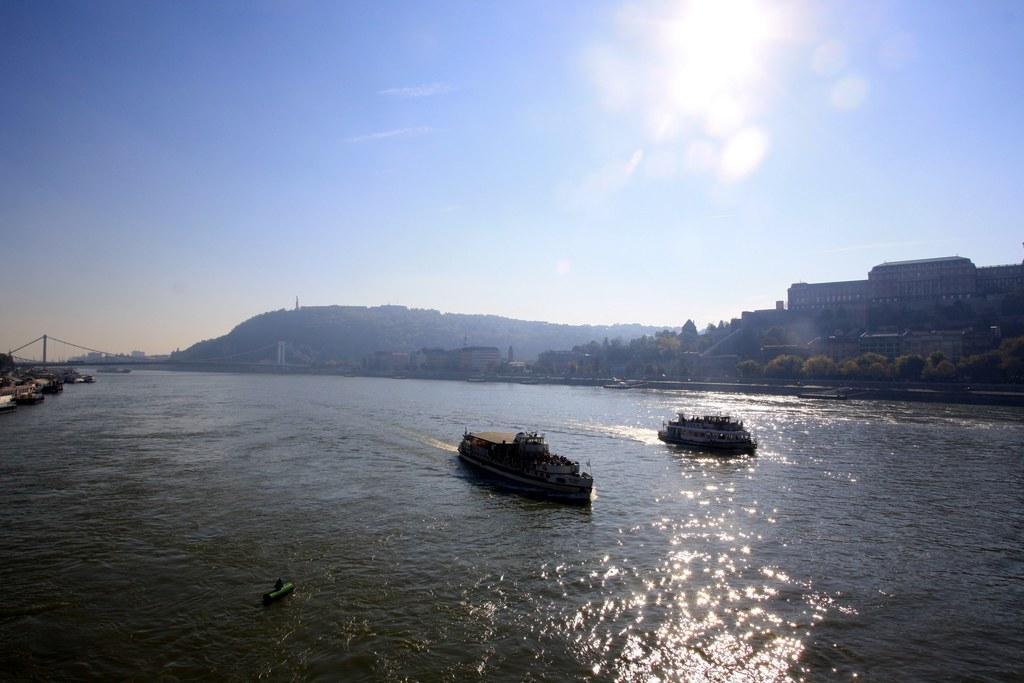How would you summarize this image in a sentence or two? In this picture we can see there are ships on the water. Behind the ships, there are trees, buildings, a hill and the sky. On the left side of the image, there is a bridge. 